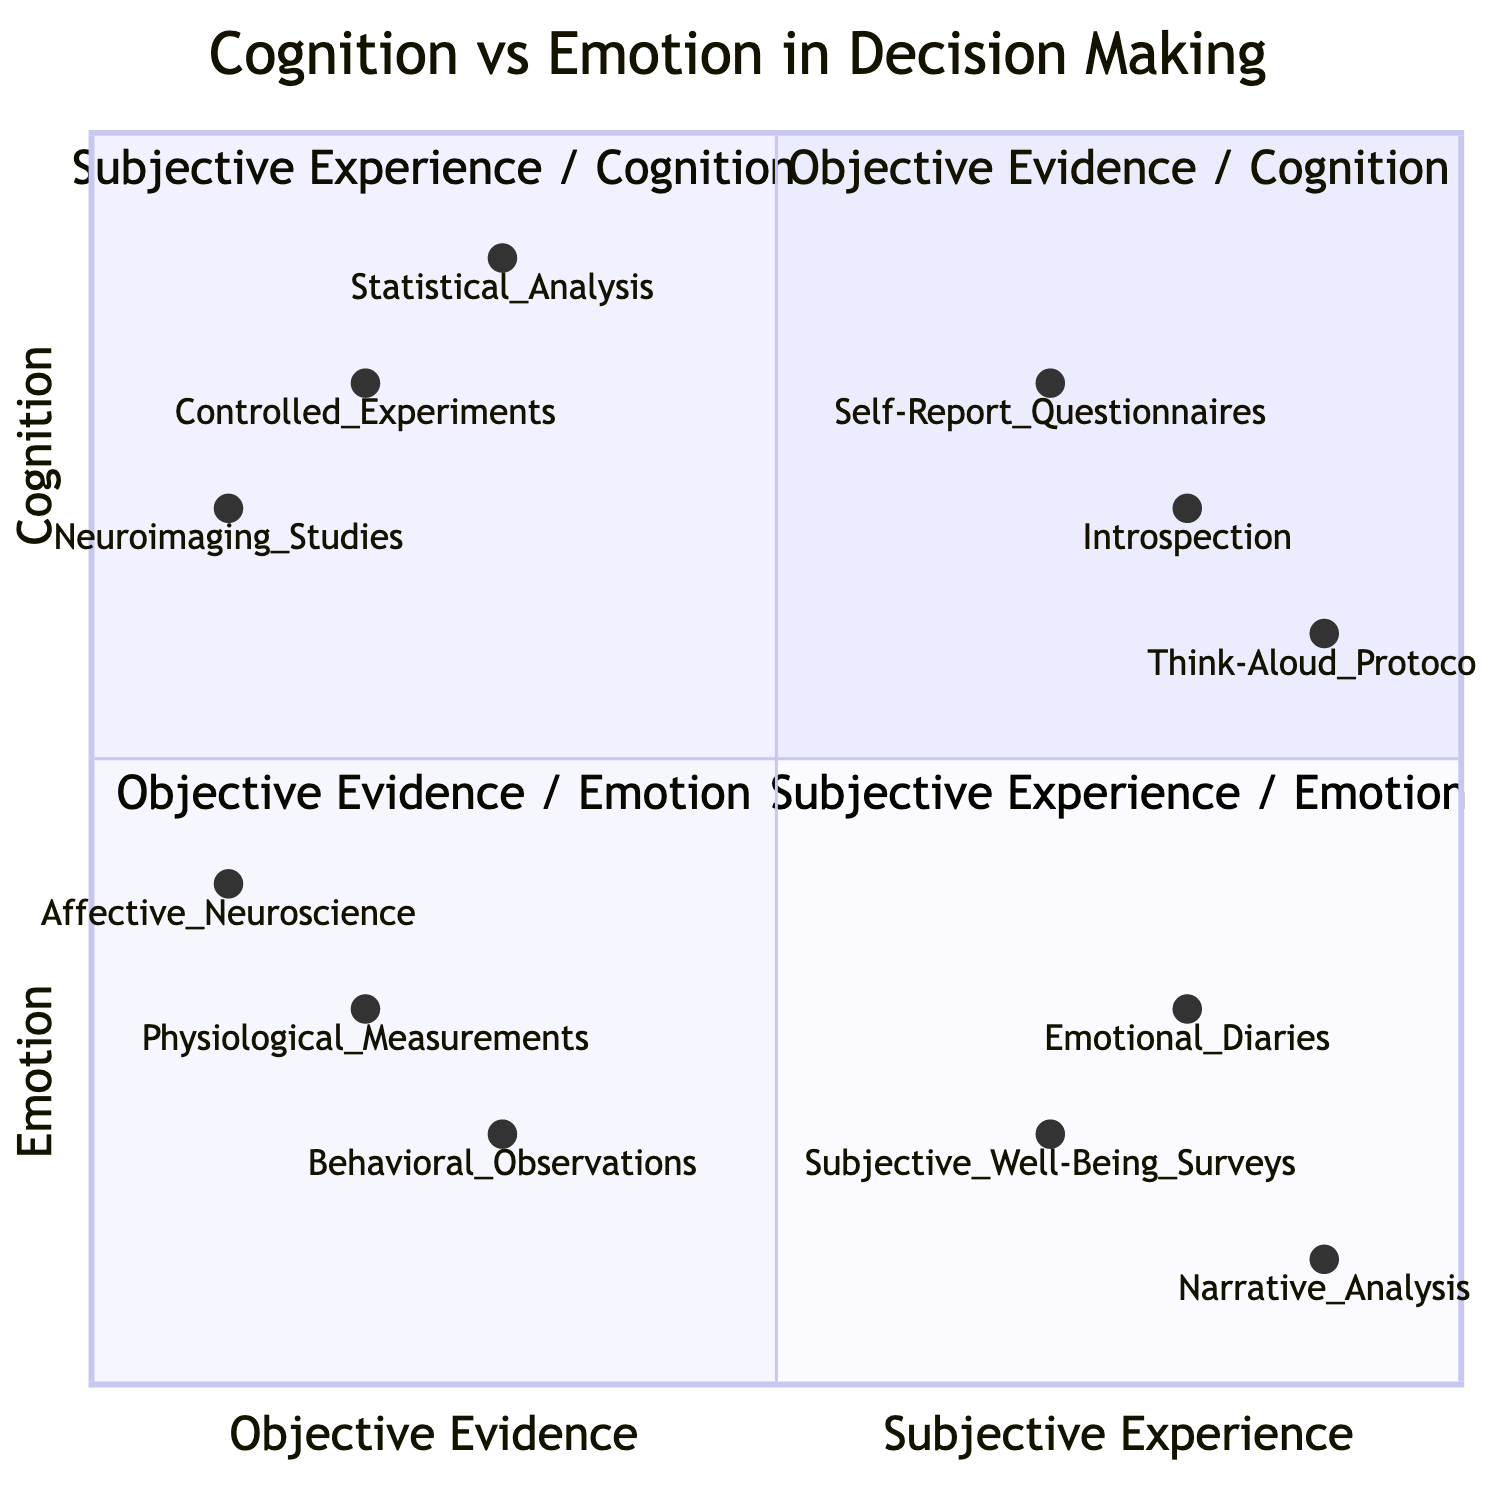What is the top example in the "Objective Evidence / Cognition" quadrant? The top example in that quadrant is "Controlled Experiments". This information is directly labeled in the diagram under the "Objective Evidence / Cognition" title.
Answer: Controlled Experiments How many examples are there in the "Subjective Experience / Emotion" quadrant? There are three examples listed in the "Subjective Experience / Emotion" quadrant: "Emotional Diaries", "Subjective Well-Being Surveys", and "Narrative Analysis". This count is determined by simply counting the examples presented under that quadrant.
Answer: 3 Which example in the "Objective Evidence / Emotion" quadrant has the lowest position? "Affective Neuroscience" is the example that appears lower than the others in the "Objective Evidence / Emotion" quadrant based on its position closer to the x-axis.
Answer: Affective Neuroscience In the "Subjective Experience / Cognition" quadrant, what is the example positioned lowest? The example positioned lowest in the "Subjective Experience / Cognition" quadrant is “Think-Aloud Protocols”, as it has the lowest y-axis value compared to "Introspection" and "Self-Report Questionnaires".
Answer: Think-Aloud Protocols Which quadrant contains "Behavioral Observations"? "Behavioral Observations" is situated in the "Objective Evidence / Emotion" quadrant, as indicated by its placement in the lower left section of the diagram.
Answer: Objective Evidence / Emotion What is the relationship in the diagram between "Self-Report Questionnaires" and "Introspection"? "Self-Report Questionnaires" is to the left of "Introspection" in the "Subjective Experience / Cognition" quadrant, indicating that it has a different emphasis on personal reflection versus structured survey data collection.
Answer: Left Which example in the "Objective Evidence / Cognition" quadrant is closest to the x-axis? "Neuroimaging Studies" is the closest to the x-axis in the "Objective Evidence / Cognition" quadrant, as it has the lowest y-value compared to the other examples in that quadrant.
Answer: Neuroimaging Studies What is the common characteristic of examples in the "Subjective Experience / Emotion" quadrant? The common characteristic is that all examples focus on personal and self-reported emotional experiences rather than objective and measurable data.
Answer: Personal emotions Which example has the highest x-axis value in the "Subjective Experience / Cognition" quadrant? "Think-Aloud Protocols" has the highest x-axis value of all examples in the "Subjective Experience / Cognition" quadrant, indicating it is the most subjective experience-focused example.
Answer: Think-Aloud Protocols 